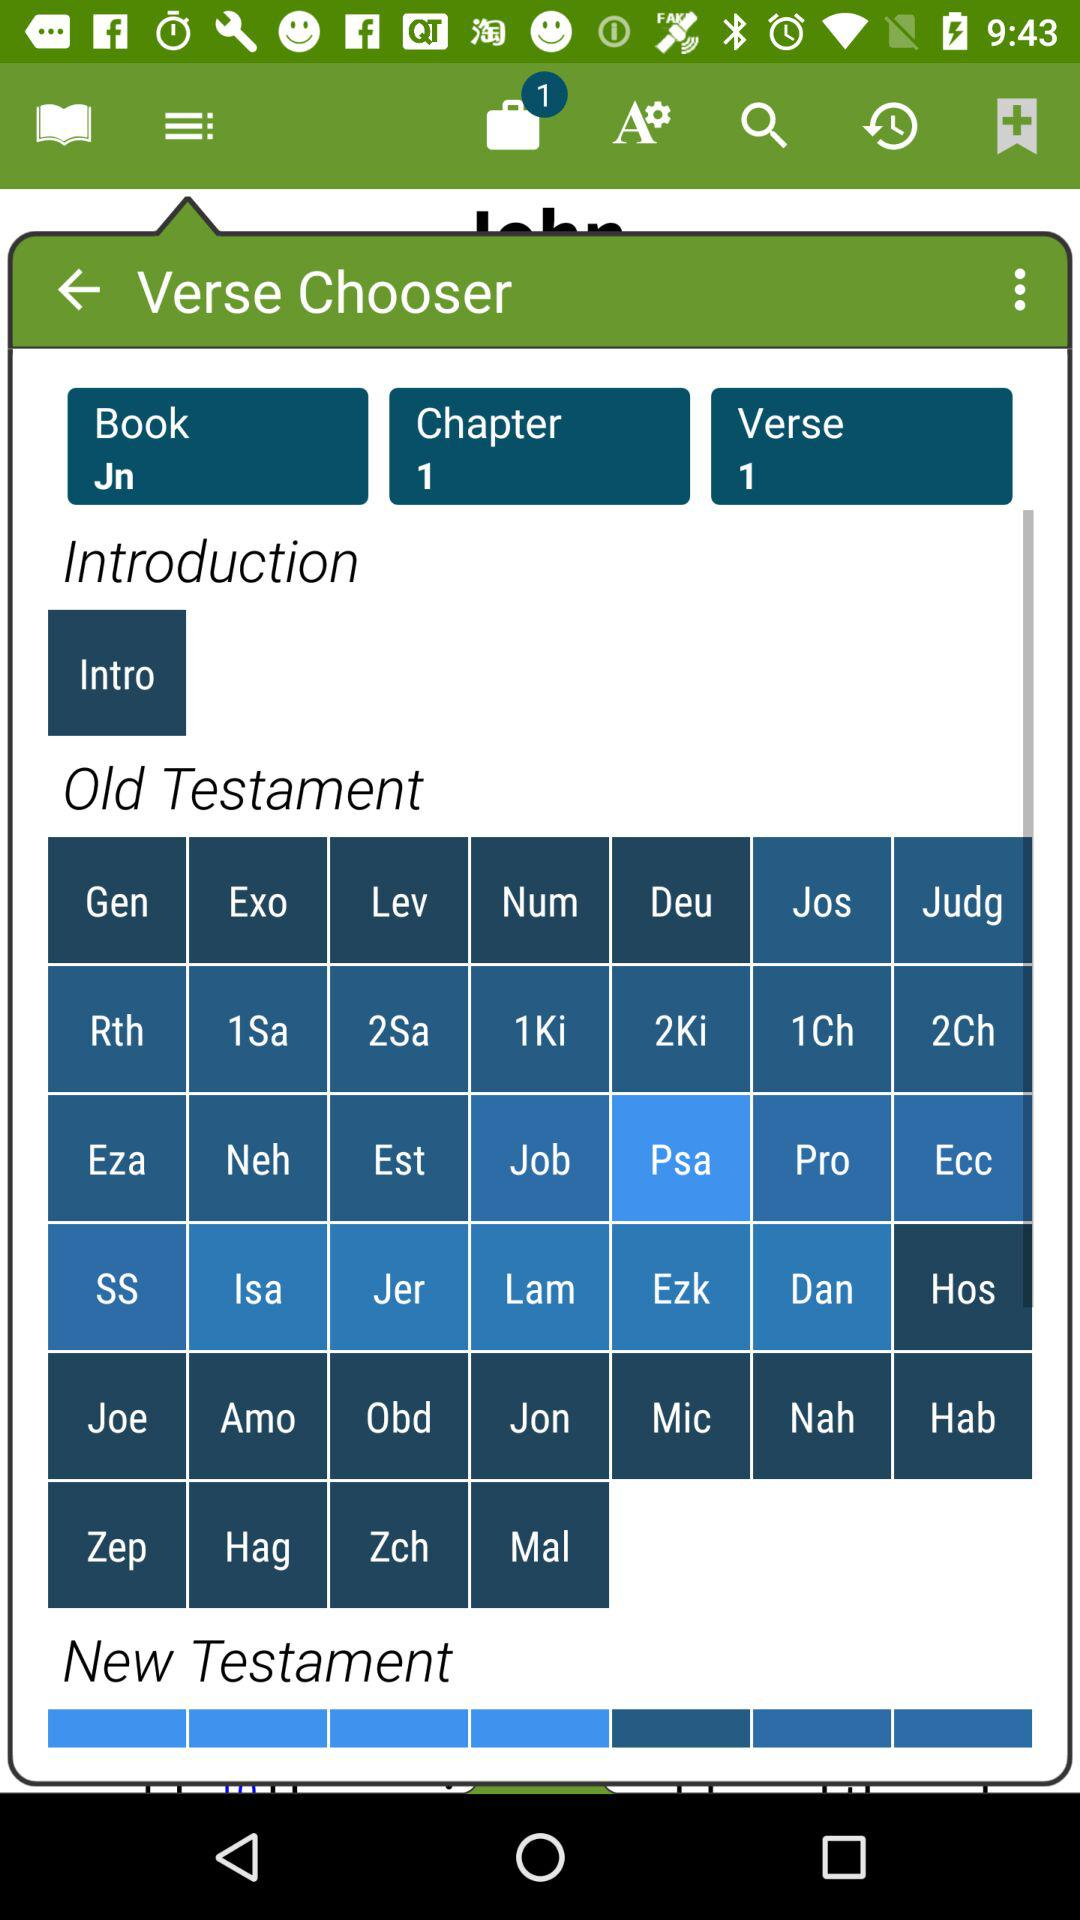How many chapters are there? There is 1 chapter. 